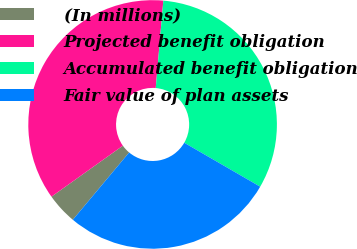<chart> <loc_0><loc_0><loc_500><loc_500><pie_chart><fcel>(In millions)<fcel>Projected benefit obligation<fcel>Accumulated benefit obligation<fcel>Fair value of plan assets<nl><fcel>4.04%<fcel>36.24%<fcel>31.97%<fcel>27.74%<nl></chart> 